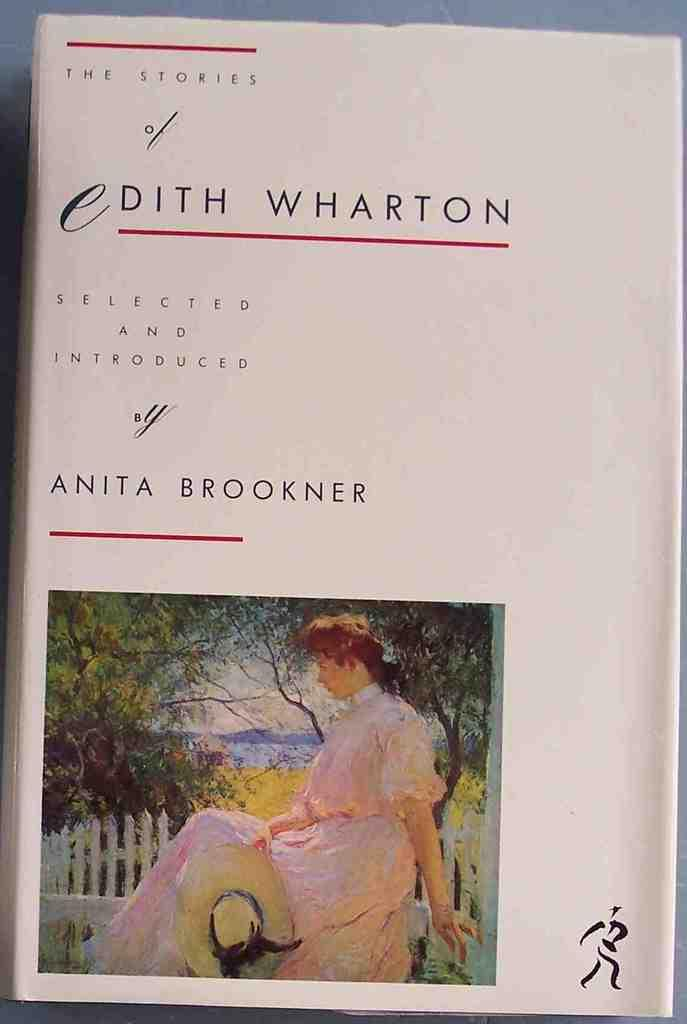<image>
Present a compact description of the photo's key features. the Cover of a book that is titled Edith Wharton 